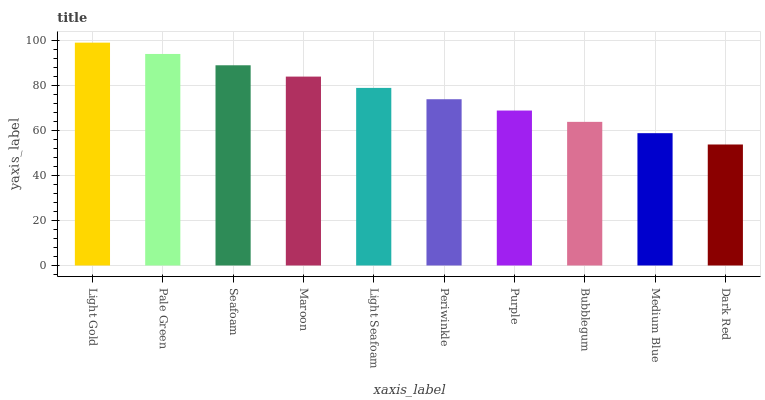Is Dark Red the minimum?
Answer yes or no. Yes. Is Light Gold the maximum?
Answer yes or no. Yes. Is Pale Green the minimum?
Answer yes or no. No. Is Pale Green the maximum?
Answer yes or no. No. Is Light Gold greater than Pale Green?
Answer yes or no. Yes. Is Pale Green less than Light Gold?
Answer yes or no. Yes. Is Pale Green greater than Light Gold?
Answer yes or no. No. Is Light Gold less than Pale Green?
Answer yes or no. No. Is Light Seafoam the high median?
Answer yes or no. Yes. Is Periwinkle the low median?
Answer yes or no. Yes. Is Medium Blue the high median?
Answer yes or no. No. Is Light Gold the low median?
Answer yes or no. No. 